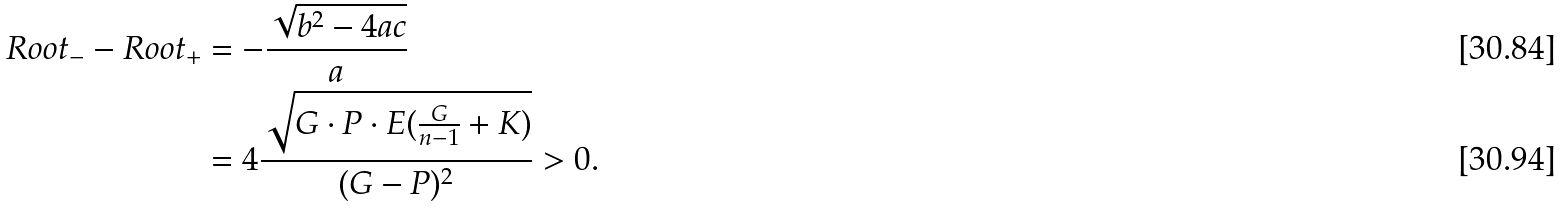<formula> <loc_0><loc_0><loc_500><loc_500>R o o t _ { - } - R o o t _ { + } & = - \frac { \sqrt { b ^ { 2 } - 4 a c } } { a } \\ & = 4 \frac { \sqrt { G \cdot P \cdot E ( \frac { G } { n - 1 } + K ) } } { ( G - P ) ^ { 2 } } > 0 .</formula> 